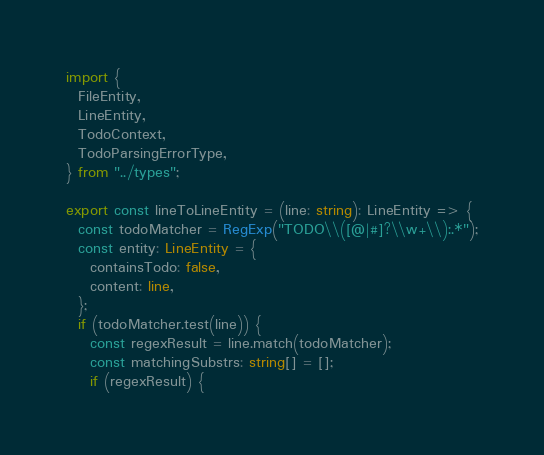<code> <loc_0><loc_0><loc_500><loc_500><_TypeScript_>import {
  FileEntity,
  LineEntity,
  TodoContext,
  TodoParsingErrorType,
} from "../types";

export const lineToLineEntity = (line: string): LineEntity => {
  const todoMatcher = RegExp("TODO\\([@|#]?\\w+\\):.*");
  const entity: LineEntity = {
    containsTodo: false,
    content: line,
  };
  if (todoMatcher.test(line)) {
    const regexResult = line.match(todoMatcher);
    const matchingSubstrs: string[] = [];
    if (regexResult) {</code> 